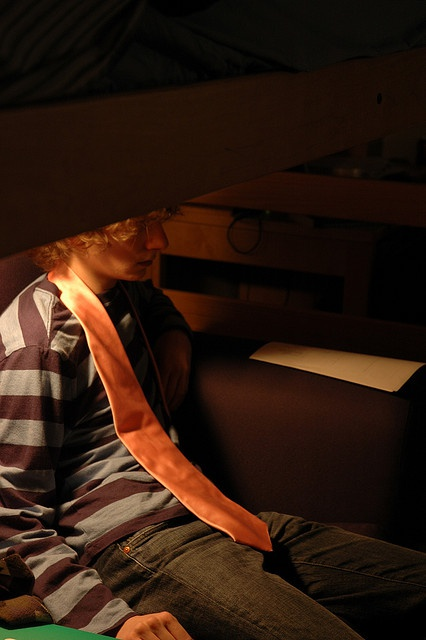Describe the objects in this image and their specific colors. I can see people in black, maroon, and gray tones, couch in black, olive, maroon, and tan tones, and tie in black, red, brown, and maroon tones in this image. 